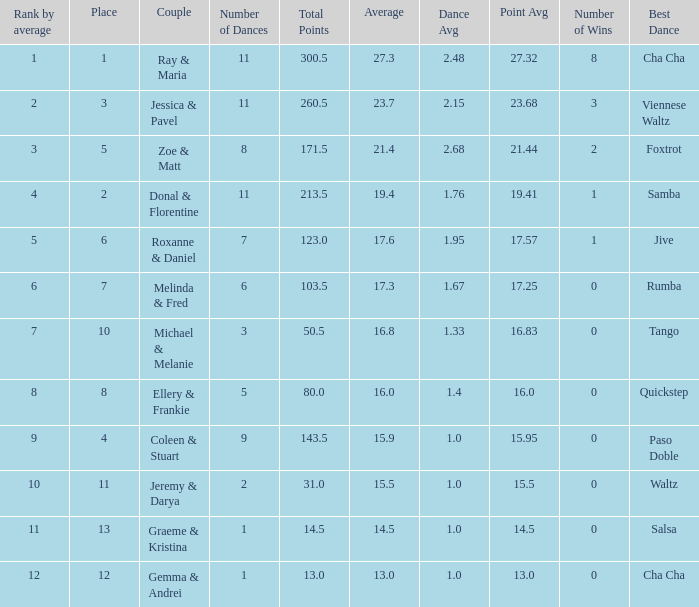What place would you be in if your rank by average is less than 2.0? 1.0. 